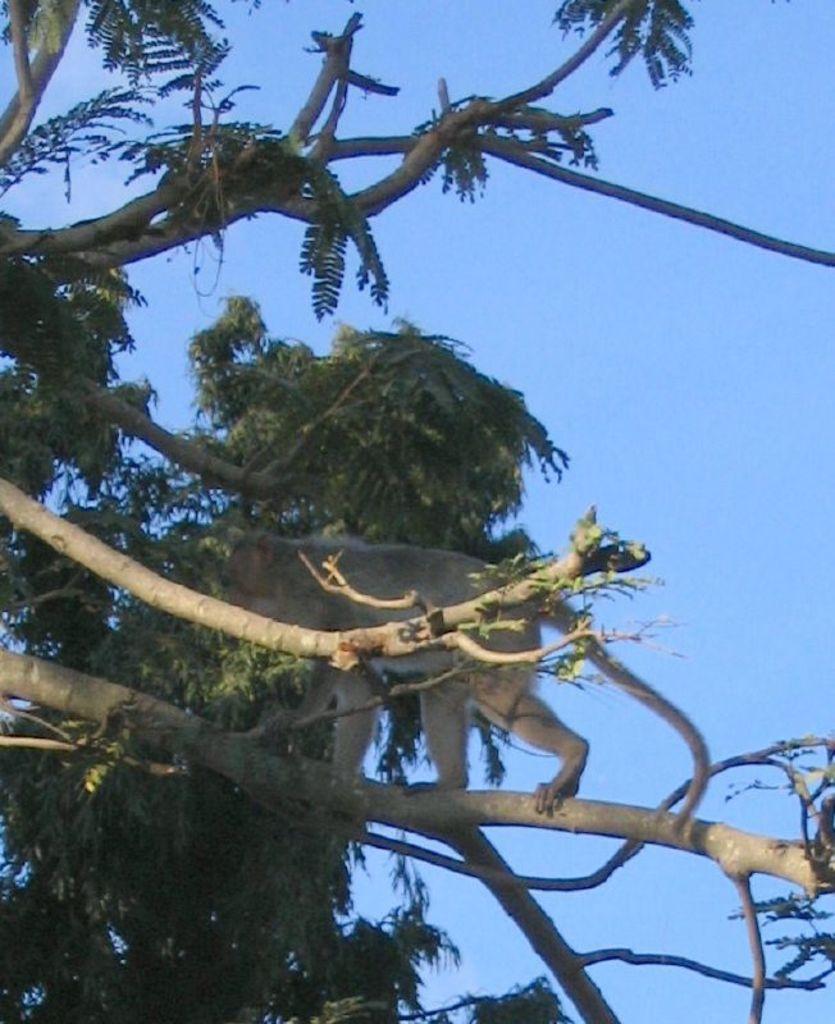In one or two sentences, can you explain what this image depicts? In this picture we can see monkey, branches and green leaves. In the background of the image we can see the sky in blue color. 